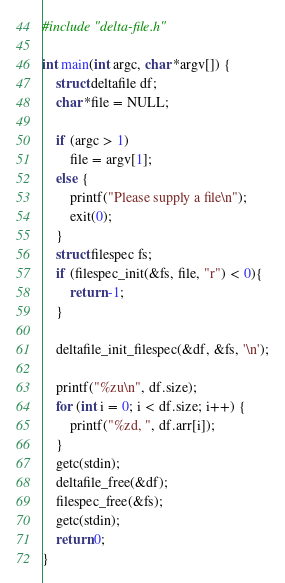<code> <loc_0><loc_0><loc_500><loc_500><_C_>#include "delta-file.h"

int main(int argc, char *argv[]) {
    struct deltafile df;
    char *file = NULL;

    if (argc > 1)
        file = argv[1];
    else {
        printf("Please supply a file\n");
        exit(0);
    }
    struct filespec fs;
    if (filespec_init(&fs, file, "r") < 0){
        return -1;
    }

    deltafile_init_filespec(&df, &fs, '\n');

    printf("%zu\n", df.size);
    for (int i = 0; i < df.size; i++) {
        printf("%zd, ", df.arr[i]);
    }
    getc(stdin);
    deltafile_free(&df);
    filespec_free(&fs);
    getc(stdin);
    return 0;
}</code> 